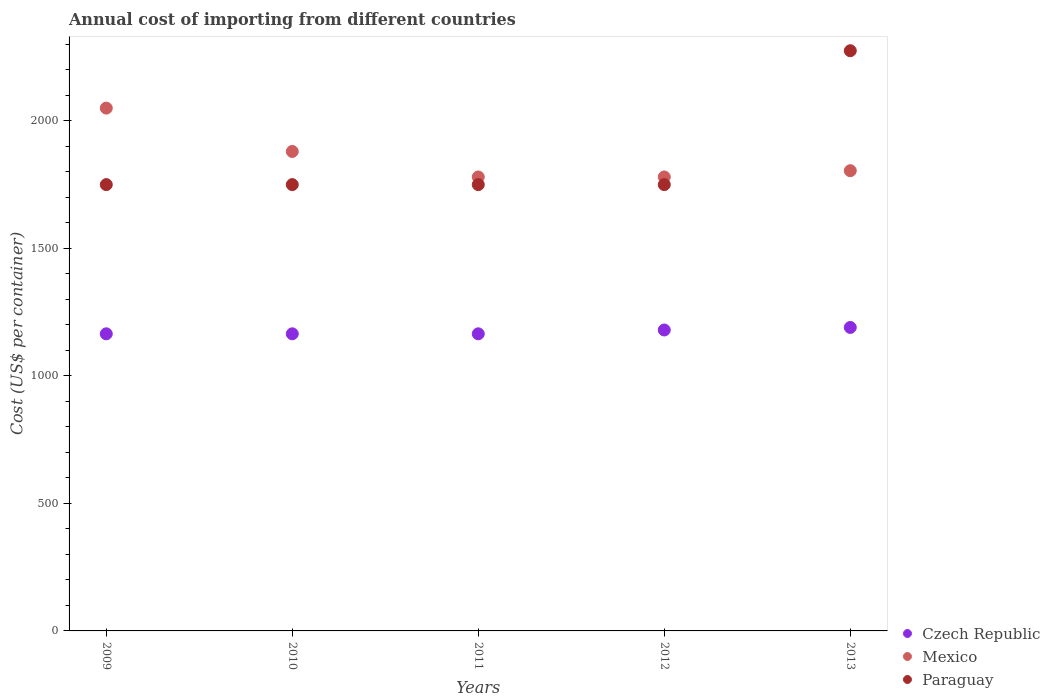How many different coloured dotlines are there?
Your response must be concise. 3. Is the number of dotlines equal to the number of legend labels?
Your response must be concise. Yes. What is the total annual cost of importing in Czech Republic in 2012?
Your response must be concise. 1180. Across all years, what is the maximum total annual cost of importing in Mexico?
Keep it short and to the point. 2050. Across all years, what is the minimum total annual cost of importing in Mexico?
Offer a terse response. 1780. What is the total total annual cost of importing in Mexico in the graph?
Your answer should be very brief. 9294.6. What is the difference between the total annual cost of importing in Czech Republic in 2011 and that in 2013?
Offer a very short reply. -25. What is the difference between the total annual cost of importing in Czech Republic in 2013 and the total annual cost of importing in Mexico in 2010?
Provide a succinct answer. -690. What is the average total annual cost of importing in Czech Republic per year?
Make the answer very short. 1173. In the year 2009, what is the difference between the total annual cost of importing in Mexico and total annual cost of importing in Paraguay?
Provide a short and direct response. 300. What is the ratio of the total annual cost of importing in Paraguay in 2010 to that in 2012?
Give a very brief answer. 1. What is the difference between the highest and the lowest total annual cost of importing in Czech Republic?
Give a very brief answer. 25. In how many years, is the total annual cost of importing in Paraguay greater than the average total annual cost of importing in Paraguay taken over all years?
Offer a very short reply. 1. What is the difference between two consecutive major ticks on the Y-axis?
Give a very brief answer. 500. Does the graph contain grids?
Give a very brief answer. No. Where does the legend appear in the graph?
Offer a very short reply. Bottom right. How are the legend labels stacked?
Ensure brevity in your answer.  Vertical. What is the title of the graph?
Make the answer very short. Annual cost of importing from different countries. Does "Philippines" appear as one of the legend labels in the graph?
Provide a short and direct response. No. What is the label or title of the X-axis?
Offer a very short reply. Years. What is the label or title of the Y-axis?
Keep it short and to the point. Cost (US$ per container). What is the Cost (US$ per container) of Czech Republic in 2009?
Offer a very short reply. 1165. What is the Cost (US$ per container) of Mexico in 2009?
Offer a terse response. 2050. What is the Cost (US$ per container) in Paraguay in 2009?
Ensure brevity in your answer.  1750. What is the Cost (US$ per container) in Czech Republic in 2010?
Your answer should be very brief. 1165. What is the Cost (US$ per container) in Mexico in 2010?
Your answer should be compact. 1880. What is the Cost (US$ per container) in Paraguay in 2010?
Make the answer very short. 1750. What is the Cost (US$ per container) of Czech Republic in 2011?
Provide a short and direct response. 1165. What is the Cost (US$ per container) in Mexico in 2011?
Provide a succinct answer. 1780. What is the Cost (US$ per container) in Paraguay in 2011?
Offer a very short reply. 1750. What is the Cost (US$ per container) in Czech Republic in 2012?
Your answer should be very brief. 1180. What is the Cost (US$ per container) in Mexico in 2012?
Offer a very short reply. 1780. What is the Cost (US$ per container) of Paraguay in 2012?
Offer a terse response. 1750. What is the Cost (US$ per container) of Czech Republic in 2013?
Your answer should be very brief. 1190. What is the Cost (US$ per container) in Mexico in 2013?
Your answer should be very brief. 1804.6. What is the Cost (US$ per container) in Paraguay in 2013?
Keep it short and to the point. 2275. Across all years, what is the maximum Cost (US$ per container) in Czech Republic?
Your response must be concise. 1190. Across all years, what is the maximum Cost (US$ per container) in Mexico?
Your answer should be very brief. 2050. Across all years, what is the maximum Cost (US$ per container) of Paraguay?
Keep it short and to the point. 2275. Across all years, what is the minimum Cost (US$ per container) of Czech Republic?
Your answer should be compact. 1165. Across all years, what is the minimum Cost (US$ per container) of Mexico?
Offer a terse response. 1780. Across all years, what is the minimum Cost (US$ per container) in Paraguay?
Keep it short and to the point. 1750. What is the total Cost (US$ per container) in Czech Republic in the graph?
Your answer should be compact. 5865. What is the total Cost (US$ per container) of Mexico in the graph?
Keep it short and to the point. 9294.6. What is the total Cost (US$ per container) in Paraguay in the graph?
Make the answer very short. 9275. What is the difference between the Cost (US$ per container) in Mexico in 2009 and that in 2010?
Offer a very short reply. 170. What is the difference between the Cost (US$ per container) of Czech Republic in 2009 and that in 2011?
Keep it short and to the point. 0. What is the difference between the Cost (US$ per container) in Mexico in 2009 and that in 2011?
Keep it short and to the point. 270. What is the difference between the Cost (US$ per container) of Paraguay in 2009 and that in 2011?
Provide a succinct answer. 0. What is the difference between the Cost (US$ per container) of Czech Republic in 2009 and that in 2012?
Offer a terse response. -15. What is the difference between the Cost (US$ per container) in Mexico in 2009 and that in 2012?
Your response must be concise. 270. What is the difference between the Cost (US$ per container) of Mexico in 2009 and that in 2013?
Provide a succinct answer. 245.4. What is the difference between the Cost (US$ per container) in Paraguay in 2009 and that in 2013?
Offer a terse response. -525. What is the difference between the Cost (US$ per container) of Czech Republic in 2010 and that in 2011?
Your response must be concise. 0. What is the difference between the Cost (US$ per container) of Czech Republic in 2010 and that in 2013?
Your answer should be very brief. -25. What is the difference between the Cost (US$ per container) of Mexico in 2010 and that in 2013?
Provide a short and direct response. 75.4. What is the difference between the Cost (US$ per container) of Paraguay in 2010 and that in 2013?
Give a very brief answer. -525. What is the difference between the Cost (US$ per container) in Mexico in 2011 and that in 2012?
Ensure brevity in your answer.  0. What is the difference between the Cost (US$ per container) in Paraguay in 2011 and that in 2012?
Give a very brief answer. 0. What is the difference between the Cost (US$ per container) of Czech Republic in 2011 and that in 2013?
Make the answer very short. -25. What is the difference between the Cost (US$ per container) in Mexico in 2011 and that in 2013?
Offer a very short reply. -24.6. What is the difference between the Cost (US$ per container) of Paraguay in 2011 and that in 2013?
Provide a succinct answer. -525. What is the difference between the Cost (US$ per container) of Czech Republic in 2012 and that in 2013?
Keep it short and to the point. -10. What is the difference between the Cost (US$ per container) of Mexico in 2012 and that in 2013?
Ensure brevity in your answer.  -24.6. What is the difference between the Cost (US$ per container) of Paraguay in 2012 and that in 2013?
Keep it short and to the point. -525. What is the difference between the Cost (US$ per container) in Czech Republic in 2009 and the Cost (US$ per container) in Mexico in 2010?
Your answer should be compact. -715. What is the difference between the Cost (US$ per container) of Czech Republic in 2009 and the Cost (US$ per container) of Paraguay in 2010?
Provide a succinct answer. -585. What is the difference between the Cost (US$ per container) in Mexico in 2009 and the Cost (US$ per container) in Paraguay in 2010?
Provide a succinct answer. 300. What is the difference between the Cost (US$ per container) of Czech Republic in 2009 and the Cost (US$ per container) of Mexico in 2011?
Offer a very short reply. -615. What is the difference between the Cost (US$ per container) in Czech Republic in 2009 and the Cost (US$ per container) in Paraguay in 2011?
Provide a short and direct response. -585. What is the difference between the Cost (US$ per container) of Mexico in 2009 and the Cost (US$ per container) of Paraguay in 2011?
Offer a terse response. 300. What is the difference between the Cost (US$ per container) in Czech Republic in 2009 and the Cost (US$ per container) in Mexico in 2012?
Your answer should be very brief. -615. What is the difference between the Cost (US$ per container) in Czech Republic in 2009 and the Cost (US$ per container) in Paraguay in 2012?
Ensure brevity in your answer.  -585. What is the difference between the Cost (US$ per container) in Mexico in 2009 and the Cost (US$ per container) in Paraguay in 2012?
Ensure brevity in your answer.  300. What is the difference between the Cost (US$ per container) in Czech Republic in 2009 and the Cost (US$ per container) in Mexico in 2013?
Offer a very short reply. -639.6. What is the difference between the Cost (US$ per container) of Czech Republic in 2009 and the Cost (US$ per container) of Paraguay in 2013?
Give a very brief answer. -1110. What is the difference between the Cost (US$ per container) of Mexico in 2009 and the Cost (US$ per container) of Paraguay in 2013?
Keep it short and to the point. -225. What is the difference between the Cost (US$ per container) in Czech Republic in 2010 and the Cost (US$ per container) in Mexico in 2011?
Your answer should be compact. -615. What is the difference between the Cost (US$ per container) in Czech Republic in 2010 and the Cost (US$ per container) in Paraguay in 2011?
Your answer should be very brief. -585. What is the difference between the Cost (US$ per container) of Mexico in 2010 and the Cost (US$ per container) of Paraguay in 2011?
Offer a very short reply. 130. What is the difference between the Cost (US$ per container) in Czech Republic in 2010 and the Cost (US$ per container) in Mexico in 2012?
Give a very brief answer. -615. What is the difference between the Cost (US$ per container) of Czech Republic in 2010 and the Cost (US$ per container) of Paraguay in 2012?
Offer a terse response. -585. What is the difference between the Cost (US$ per container) of Mexico in 2010 and the Cost (US$ per container) of Paraguay in 2012?
Ensure brevity in your answer.  130. What is the difference between the Cost (US$ per container) of Czech Republic in 2010 and the Cost (US$ per container) of Mexico in 2013?
Give a very brief answer. -639.6. What is the difference between the Cost (US$ per container) of Czech Republic in 2010 and the Cost (US$ per container) of Paraguay in 2013?
Keep it short and to the point. -1110. What is the difference between the Cost (US$ per container) in Mexico in 2010 and the Cost (US$ per container) in Paraguay in 2013?
Give a very brief answer. -395. What is the difference between the Cost (US$ per container) in Czech Republic in 2011 and the Cost (US$ per container) in Mexico in 2012?
Provide a succinct answer. -615. What is the difference between the Cost (US$ per container) of Czech Republic in 2011 and the Cost (US$ per container) of Paraguay in 2012?
Your answer should be compact. -585. What is the difference between the Cost (US$ per container) of Mexico in 2011 and the Cost (US$ per container) of Paraguay in 2012?
Keep it short and to the point. 30. What is the difference between the Cost (US$ per container) in Czech Republic in 2011 and the Cost (US$ per container) in Mexico in 2013?
Your answer should be very brief. -639.6. What is the difference between the Cost (US$ per container) in Czech Republic in 2011 and the Cost (US$ per container) in Paraguay in 2013?
Keep it short and to the point. -1110. What is the difference between the Cost (US$ per container) of Mexico in 2011 and the Cost (US$ per container) of Paraguay in 2013?
Give a very brief answer. -495. What is the difference between the Cost (US$ per container) of Czech Republic in 2012 and the Cost (US$ per container) of Mexico in 2013?
Your answer should be very brief. -624.6. What is the difference between the Cost (US$ per container) in Czech Republic in 2012 and the Cost (US$ per container) in Paraguay in 2013?
Make the answer very short. -1095. What is the difference between the Cost (US$ per container) of Mexico in 2012 and the Cost (US$ per container) of Paraguay in 2013?
Keep it short and to the point. -495. What is the average Cost (US$ per container) in Czech Republic per year?
Ensure brevity in your answer.  1173. What is the average Cost (US$ per container) in Mexico per year?
Keep it short and to the point. 1858.92. What is the average Cost (US$ per container) in Paraguay per year?
Provide a succinct answer. 1855. In the year 2009, what is the difference between the Cost (US$ per container) in Czech Republic and Cost (US$ per container) in Mexico?
Your answer should be very brief. -885. In the year 2009, what is the difference between the Cost (US$ per container) of Czech Republic and Cost (US$ per container) of Paraguay?
Offer a very short reply. -585. In the year 2009, what is the difference between the Cost (US$ per container) of Mexico and Cost (US$ per container) of Paraguay?
Provide a short and direct response. 300. In the year 2010, what is the difference between the Cost (US$ per container) in Czech Republic and Cost (US$ per container) in Mexico?
Provide a short and direct response. -715. In the year 2010, what is the difference between the Cost (US$ per container) of Czech Republic and Cost (US$ per container) of Paraguay?
Offer a terse response. -585. In the year 2010, what is the difference between the Cost (US$ per container) in Mexico and Cost (US$ per container) in Paraguay?
Ensure brevity in your answer.  130. In the year 2011, what is the difference between the Cost (US$ per container) in Czech Republic and Cost (US$ per container) in Mexico?
Keep it short and to the point. -615. In the year 2011, what is the difference between the Cost (US$ per container) of Czech Republic and Cost (US$ per container) of Paraguay?
Your response must be concise. -585. In the year 2012, what is the difference between the Cost (US$ per container) of Czech Republic and Cost (US$ per container) of Mexico?
Provide a short and direct response. -600. In the year 2012, what is the difference between the Cost (US$ per container) in Czech Republic and Cost (US$ per container) in Paraguay?
Offer a very short reply. -570. In the year 2013, what is the difference between the Cost (US$ per container) of Czech Republic and Cost (US$ per container) of Mexico?
Provide a succinct answer. -614.6. In the year 2013, what is the difference between the Cost (US$ per container) of Czech Republic and Cost (US$ per container) of Paraguay?
Offer a terse response. -1085. In the year 2013, what is the difference between the Cost (US$ per container) of Mexico and Cost (US$ per container) of Paraguay?
Provide a succinct answer. -470.4. What is the ratio of the Cost (US$ per container) in Mexico in 2009 to that in 2010?
Your response must be concise. 1.09. What is the ratio of the Cost (US$ per container) of Paraguay in 2009 to that in 2010?
Provide a short and direct response. 1. What is the ratio of the Cost (US$ per container) in Czech Republic in 2009 to that in 2011?
Your response must be concise. 1. What is the ratio of the Cost (US$ per container) of Mexico in 2009 to that in 2011?
Offer a terse response. 1.15. What is the ratio of the Cost (US$ per container) in Paraguay in 2009 to that in 2011?
Keep it short and to the point. 1. What is the ratio of the Cost (US$ per container) in Czech Republic in 2009 to that in 2012?
Offer a terse response. 0.99. What is the ratio of the Cost (US$ per container) of Mexico in 2009 to that in 2012?
Provide a succinct answer. 1.15. What is the ratio of the Cost (US$ per container) in Paraguay in 2009 to that in 2012?
Provide a short and direct response. 1. What is the ratio of the Cost (US$ per container) of Mexico in 2009 to that in 2013?
Your response must be concise. 1.14. What is the ratio of the Cost (US$ per container) of Paraguay in 2009 to that in 2013?
Provide a short and direct response. 0.77. What is the ratio of the Cost (US$ per container) in Czech Republic in 2010 to that in 2011?
Offer a very short reply. 1. What is the ratio of the Cost (US$ per container) in Mexico in 2010 to that in 2011?
Offer a terse response. 1.06. What is the ratio of the Cost (US$ per container) of Paraguay in 2010 to that in 2011?
Ensure brevity in your answer.  1. What is the ratio of the Cost (US$ per container) in Czech Republic in 2010 to that in 2012?
Your answer should be compact. 0.99. What is the ratio of the Cost (US$ per container) in Mexico in 2010 to that in 2012?
Keep it short and to the point. 1.06. What is the ratio of the Cost (US$ per container) of Paraguay in 2010 to that in 2012?
Provide a succinct answer. 1. What is the ratio of the Cost (US$ per container) in Mexico in 2010 to that in 2013?
Ensure brevity in your answer.  1.04. What is the ratio of the Cost (US$ per container) of Paraguay in 2010 to that in 2013?
Provide a succinct answer. 0.77. What is the ratio of the Cost (US$ per container) in Czech Republic in 2011 to that in 2012?
Offer a terse response. 0.99. What is the ratio of the Cost (US$ per container) of Mexico in 2011 to that in 2012?
Your response must be concise. 1. What is the ratio of the Cost (US$ per container) in Czech Republic in 2011 to that in 2013?
Your answer should be very brief. 0.98. What is the ratio of the Cost (US$ per container) of Mexico in 2011 to that in 2013?
Give a very brief answer. 0.99. What is the ratio of the Cost (US$ per container) in Paraguay in 2011 to that in 2013?
Your response must be concise. 0.77. What is the ratio of the Cost (US$ per container) in Czech Republic in 2012 to that in 2013?
Offer a very short reply. 0.99. What is the ratio of the Cost (US$ per container) in Mexico in 2012 to that in 2013?
Make the answer very short. 0.99. What is the ratio of the Cost (US$ per container) of Paraguay in 2012 to that in 2013?
Ensure brevity in your answer.  0.77. What is the difference between the highest and the second highest Cost (US$ per container) of Czech Republic?
Offer a terse response. 10. What is the difference between the highest and the second highest Cost (US$ per container) of Mexico?
Provide a succinct answer. 170. What is the difference between the highest and the second highest Cost (US$ per container) in Paraguay?
Make the answer very short. 525. What is the difference between the highest and the lowest Cost (US$ per container) in Mexico?
Keep it short and to the point. 270. What is the difference between the highest and the lowest Cost (US$ per container) of Paraguay?
Keep it short and to the point. 525. 